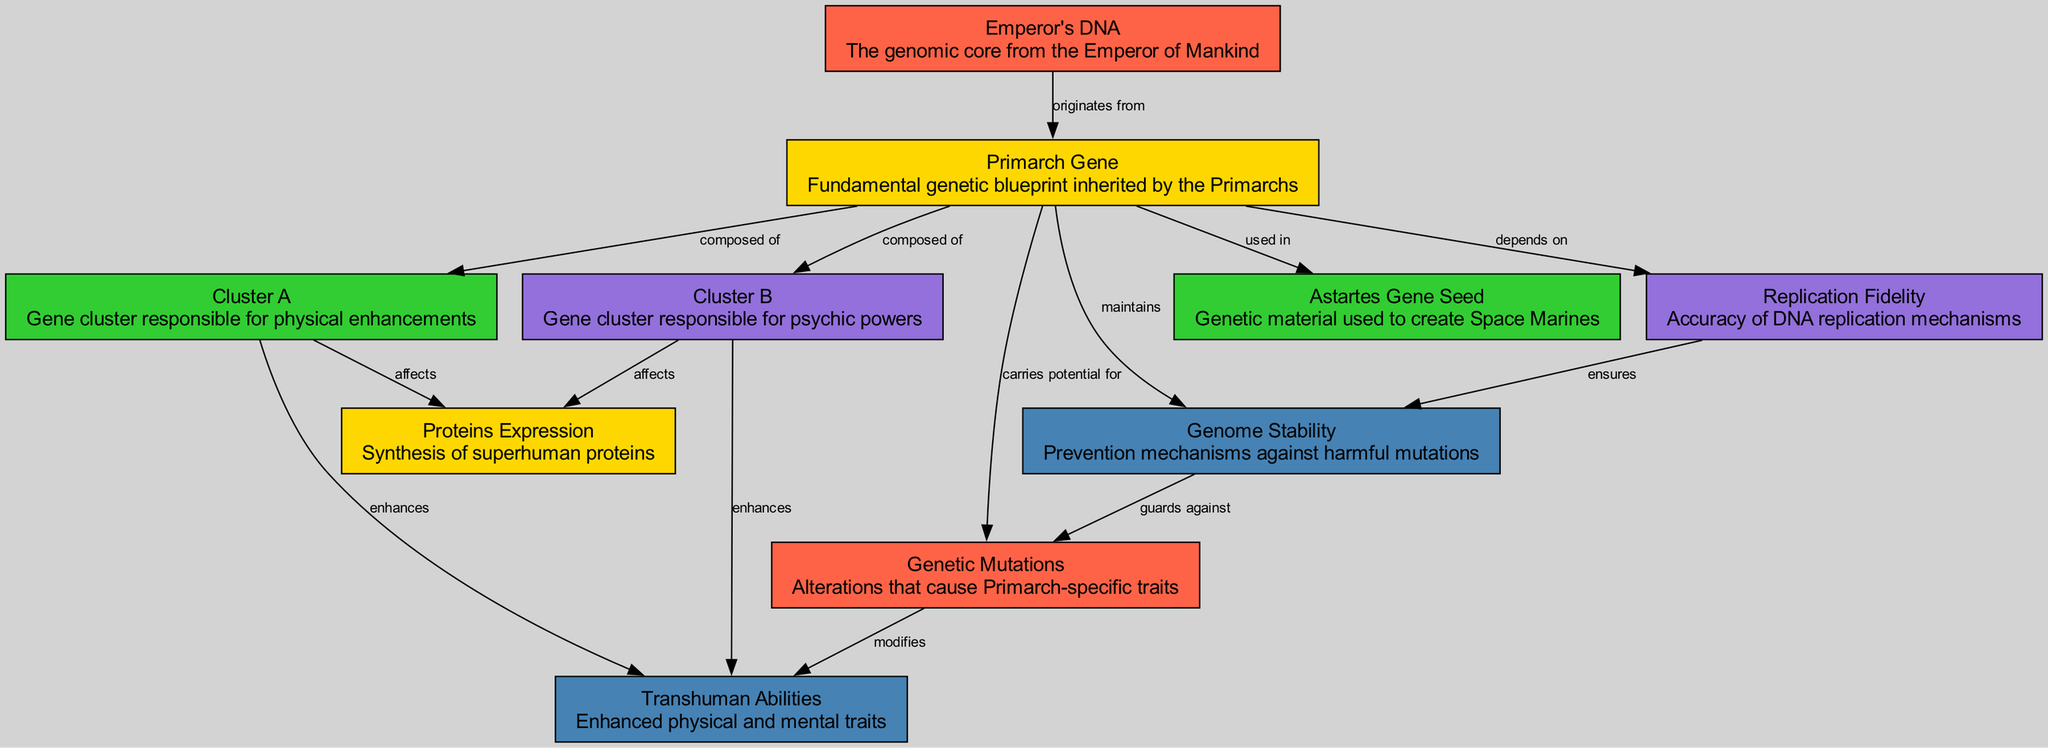What is the originating source of the Primarch Gene? The diagram shows that the Primarch Gene originates from the Emperor's DNA, as indicated by the edge labeled "originates from" connecting these two nodes.
Answer: Emperor's DNA How many gene clusters are composed within the Primarch Gene? The diagram reveals two components that are listed under the Primarch Gene: Cluster A and Cluster B, making the total count of gene clusters two.
Answer: 2 What type of abilities do both Cluster A and Cluster B enhance? Both Cluster A and Cluster B are connected to Transhuman Abilities through the labeled edges "enhances." This indicates that they contribute to enhanced abilities in Primarchs.
Answer: Transhuman Abilities What does the Primarch Gene depend on for maintaining replication accuracy? The diagram shows a direct connection from the Primarch Gene to the Replication Fidelity node, labeled "depends on," indicating that the accuracy of DNA replication is contingent on the Primarch Gene.
Answer: Replication Fidelity Which gene cluster affects Proteins Expression? The diagram exhibits connections from both Cluster A and Cluster B to the Proteins Expression node, which are labeled "affects." Hence, both gene clusters influence the expression of superhuman proteins.
Answer: Cluster A and Cluster B What does Genome Stability guard against? According to the diagram, Genome Stability is connected to the Genetic Mutations node, with the edge labeled "guards against," suggesting that it protects the genome against harmful alterations.
Answer: Genetic Mutations How are Genetic Mutations described in the context of the Primarch Gene? The diagram highlights that Genetic Mutations are potential alterations carried by the Primarch Gene as indicated by the edge labeled "carries potential for."
Answer: Alterations What is the function of the Astartes Gene Seed in relation to the Primarch Gene? The edge labeled "used in" indicates that the Astartes Gene Seed is derived from or associated with the Primarch Gene, suggesting a role in the creation of Space Marines.
Answer: Creation of Space Marines 